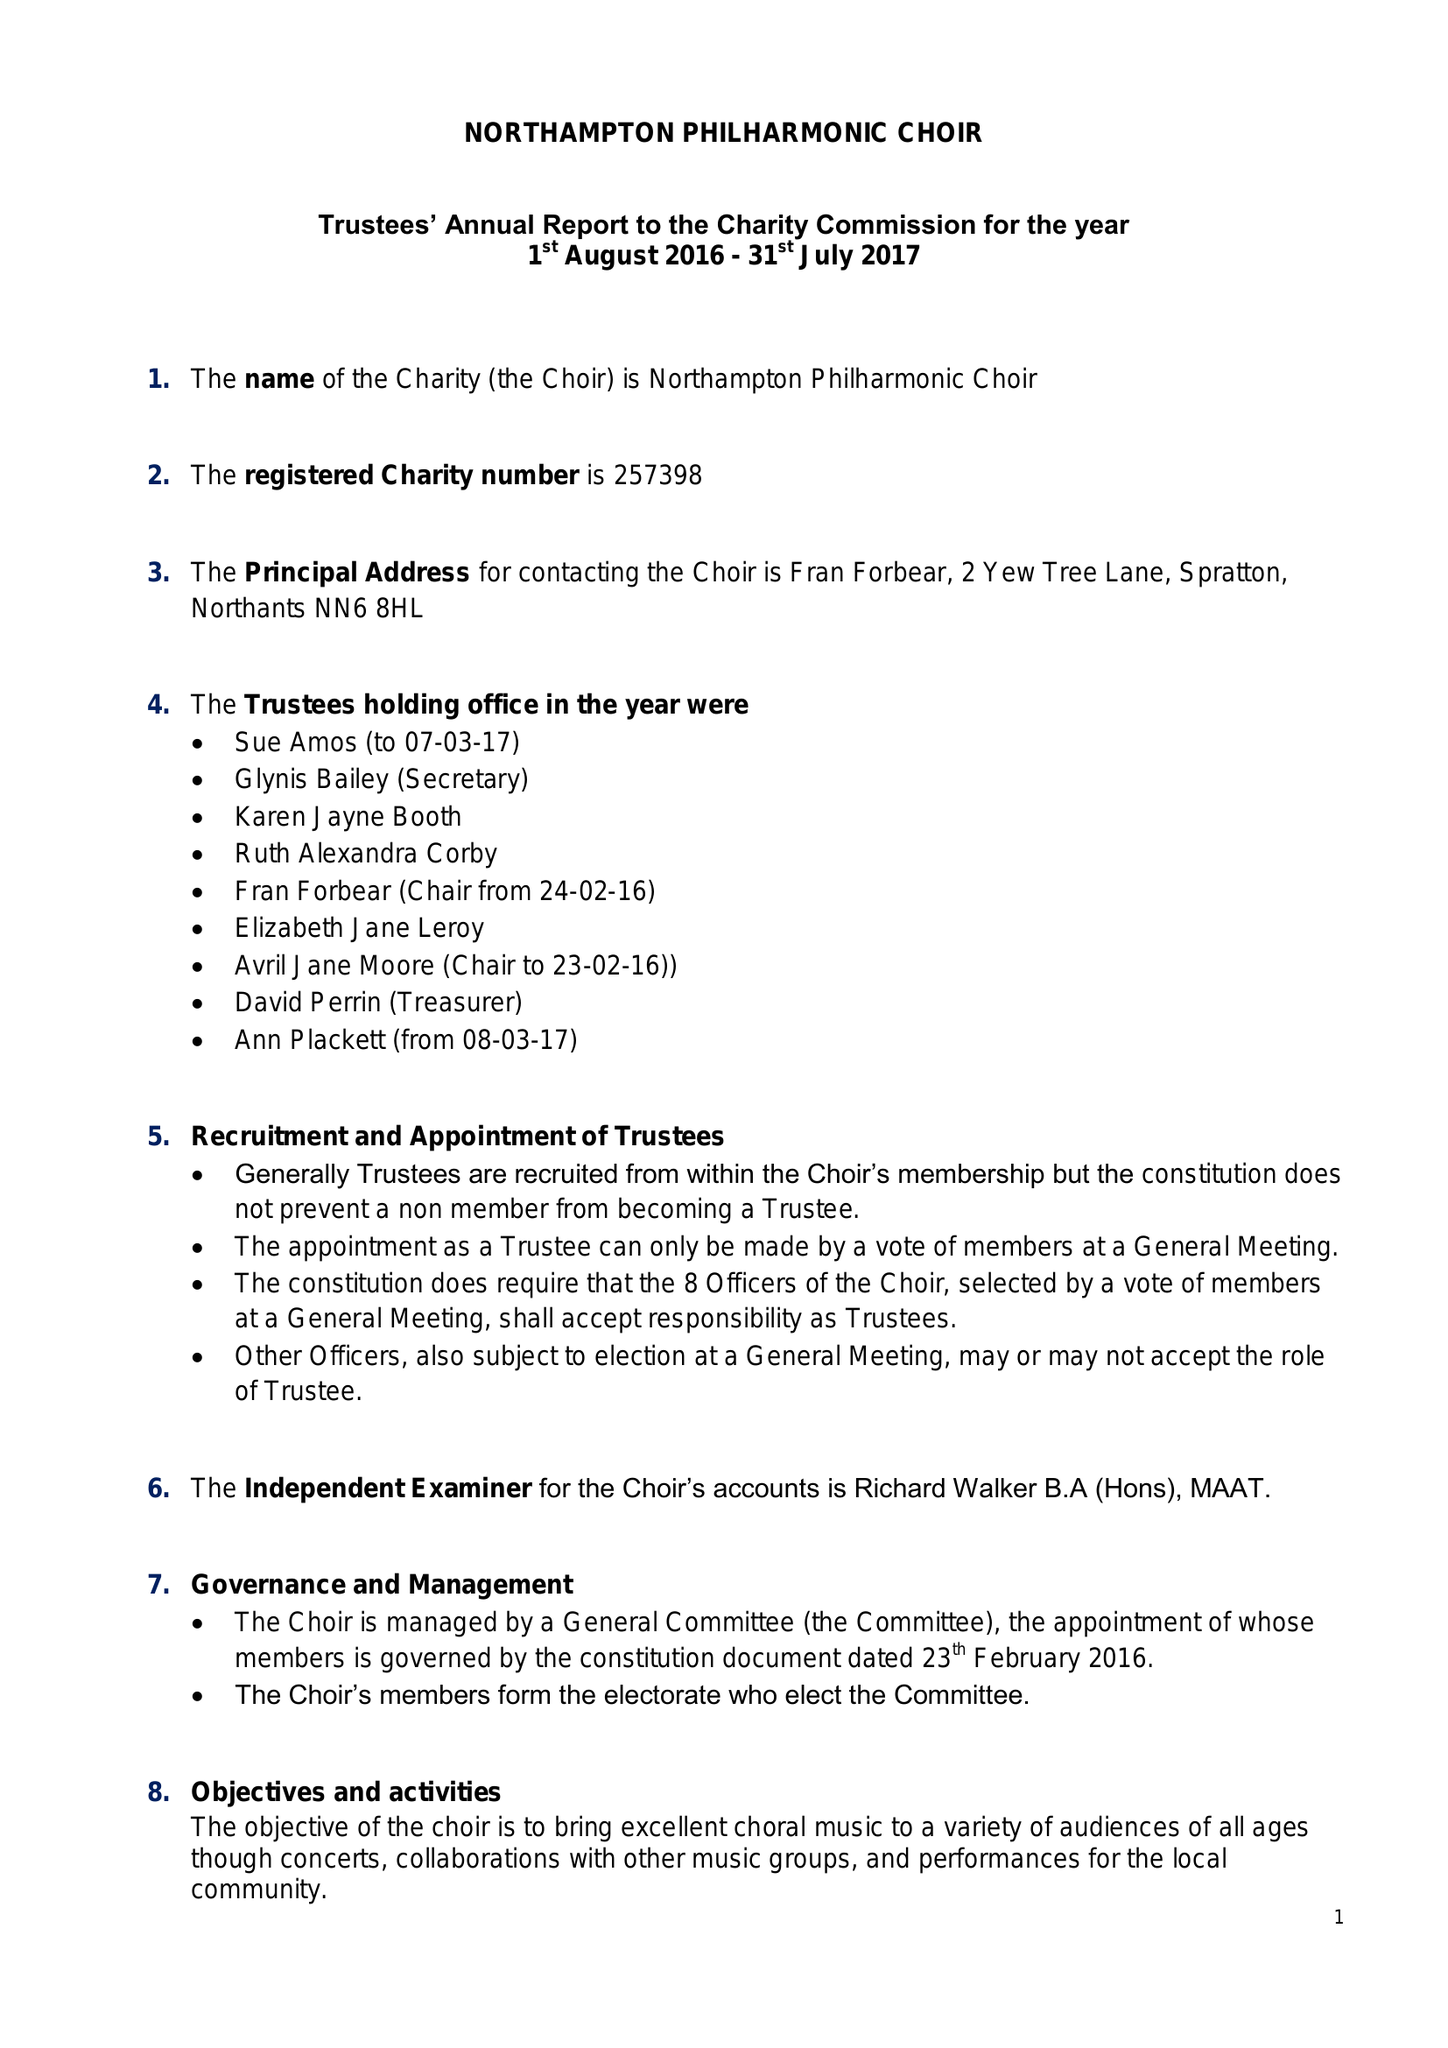What is the value for the address__post_town?
Answer the question using a single word or phrase. NORTHAMPTON 